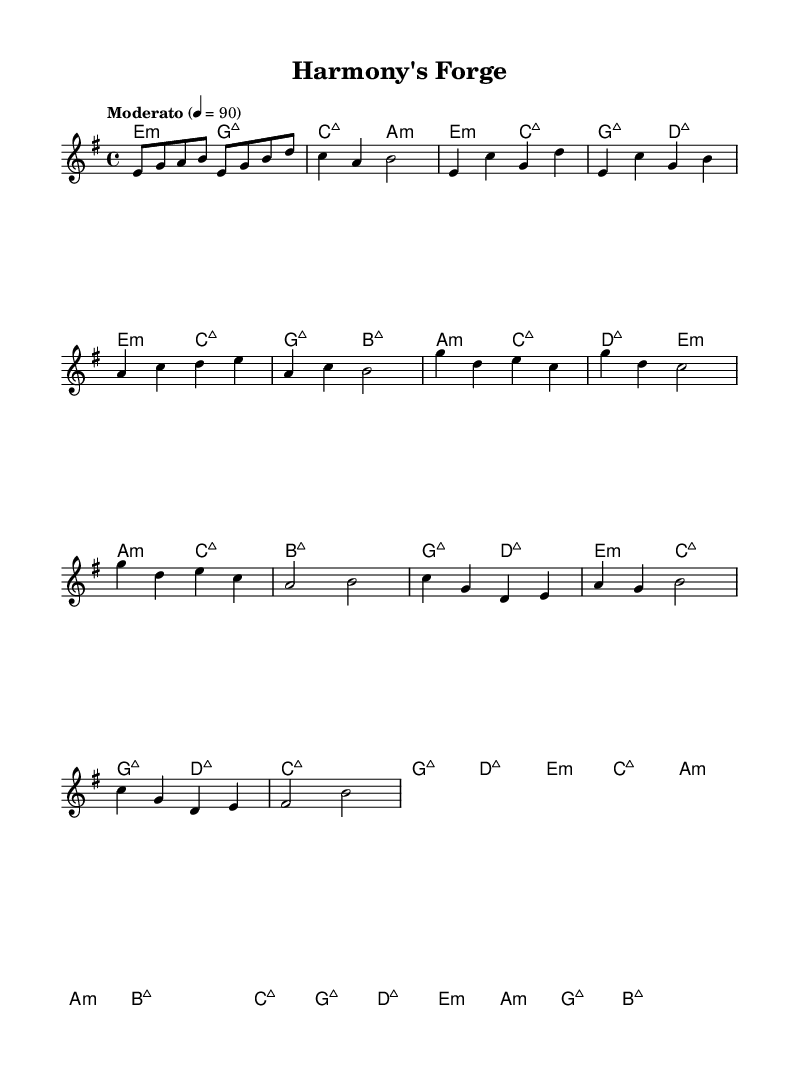What is the key signature of this music? The key signature is E minor, which has one sharp (F#). This can be determined by looking at the key signature notation at the beginning of the score, which identifies E minor.
Answer: E minor What is the time signature of the music? The time signature is 4/4, which is indicated at the beginning of the score. This means there are four beats in each measure and the quarter note gets one beat.
Answer: 4/4 What is the tempo marking of this piece? The tempo marking is "Moderato," which signifies a moderately paced tempo. This is noted in the score above the staff.
Answer: Moderato How many measures are in the chorus section? The chorus section consists of 4 measures, as indicated by the notation in the score during that specific part of the piece.
Answer: 4 What is the last chord of the piece? The last chord indicated in the harmonies section is B major, which is seen at the end of the bridge.
Answer: B major How does the melody of the chorus begin? The melody of the chorus begins with the note G, as the first note of the chorus measures shows the pitch G.
Answer: G Which musical section is characterized by the lyric "Harmony’s Forge"? The title "Harmony's Forge" suggests it represents the overall theme of unity and peace, inferring it encapsulates both the verse and the chorus sections where these themes are prominent.
Answer: Verse and Chorus 